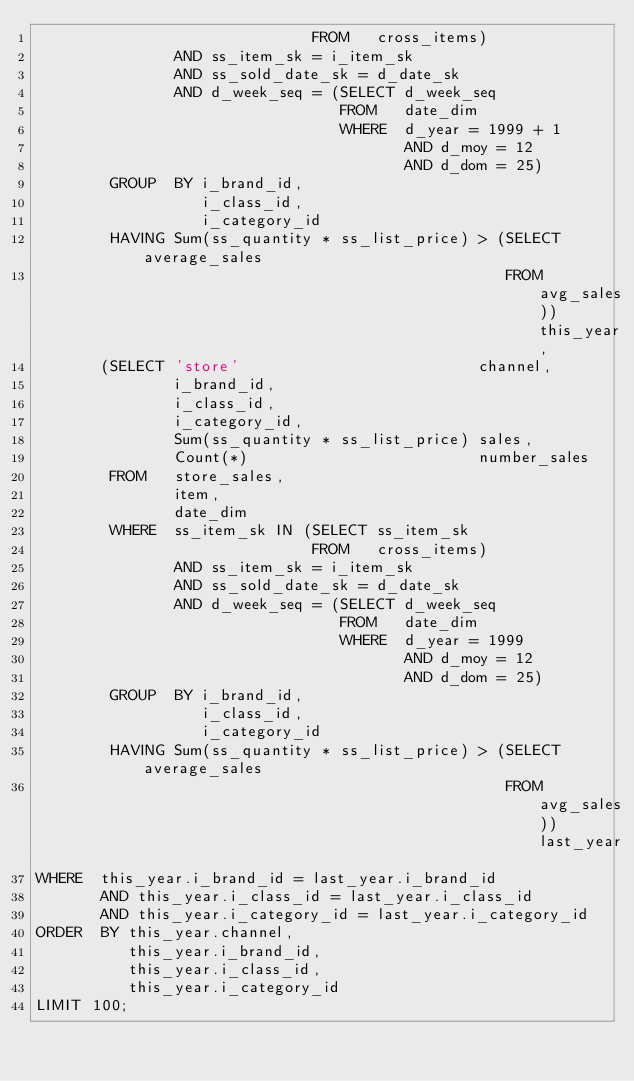Convert code to text. <code><loc_0><loc_0><loc_500><loc_500><_SQL_>                              FROM   cross_items) 
               AND ss_item_sk = i_item_sk 
               AND ss_sold_date_sk = d_date_sk 
               AND d_week_seq = (SELECT d_week_seq 
                                 FROM   date_dim 
                                 WHERE  d_year = 1999 + 1 
                                        AND d_moy = 12 
                                        AND d_dom = 25) 
        GROUP  BY i_brand_id, 
                  i_class_id, 
                  i_category_id 
        HAVING Sum(ss_quantity * ss_list_price) > (SELECT average_sales 
                                                   FROM   avg_sales)) this_year, 
       (SELECT 'store'                          channel, 
               i_brand_id, 
               i_class_id, 
               i_category_id, 
               Sum(ss_quantity * ss_list_price) sales, 
               Count(*)                         number_sales 
        FROM   store_sales, 
               item, 
               date_dim 
        WHERE  ss_item_sk IN (SELECT ss_item_sk 
                              FROM   cross_items) 
               AND ss_item_sk = i_item_sk 
               AND ss_sold_date_sk = d_date_sk 
               AND d_week_seq = (SELECT d_week_seq 
                                 FROM   date_dim 
                                 WHERE  d_year = 1999 
                                        AND d_moy = 12 
                                        AND d_dom = 25) 
        GROUP  BY i_brand_id, 
                  i_class_id, 
                  i_category_id 
        HAVING Sum(ss_quantity * ss_list_price) > (SELECT average_sales 
                                                   FROM   avg_sales)) last_year 
WHERE  this_year.i_brand_id = last_year.i_brand_id 
       AND this_year.i_class_id = last_year.i_class_id 
       AND this_year.i_category_id = last_year.i_category_id 
ORDER  BY this_year.channel, 
          this_year.i_brand_id, 
          this_year.i_class_id, 
          this_year.i_category_id
LIMIT 100; 
</code> 